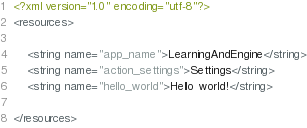<code> <loc_0><loc_0><loc_500><loc_500><_XML_><?xml version="1.0" encoding="utf-8"?>
<resources>

    <string name="app_name">LearningAndEngine</string>
    <string name="action_settings">Settings</string>
    <string name="hello_world">Hello world!</string>

</resources>
</code> 